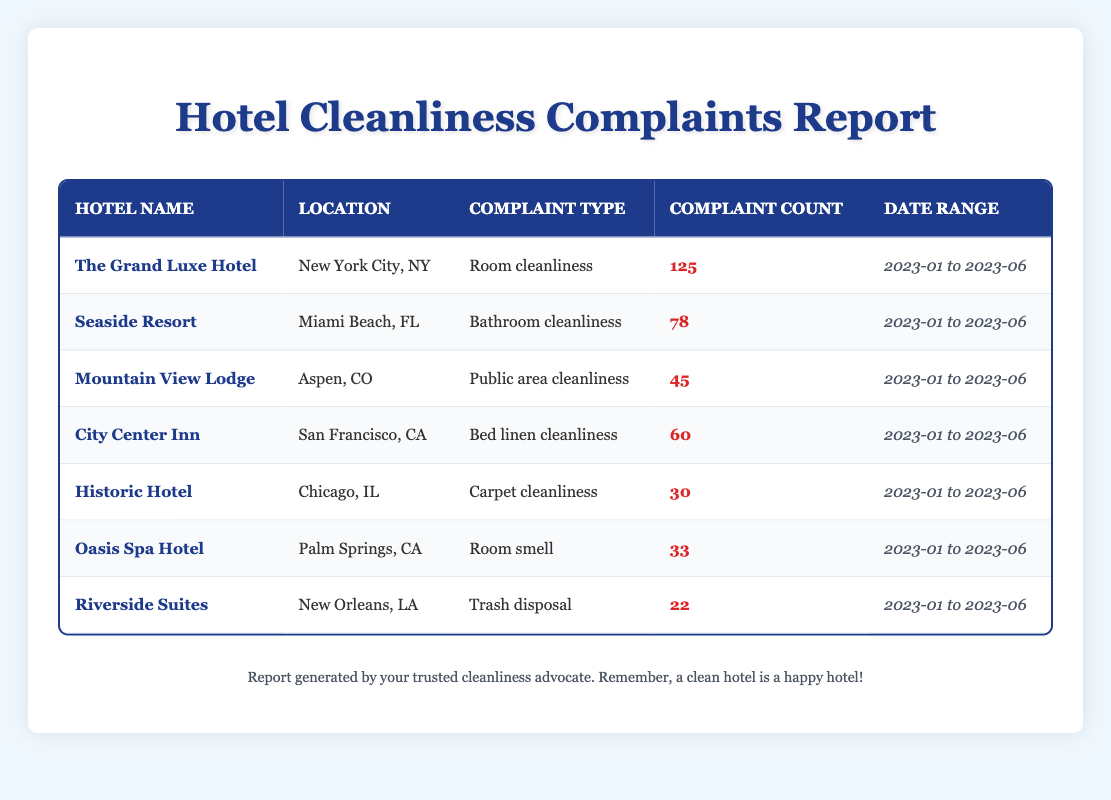What hotel had the highest number of cleanliness-related complaints? By reviewing the data in the table, we can see that "The Grand Luxe Hotel" has a complaint count of 125, which is the highest compared to other hotels listed.
Answer: The Grand Luxe Hotel Which hotel received complaints about bathroom cleanliness? Looking through the table, "Seaside Resort" is specifically noted for complaints related to bathroom cleanliness with a complaint count of 78.
Answer: Seaside Resort What is the total number of complaints related to cleanliness for the hotels listed? To find the total, we sum the complaint counts for all hotels: 125 + 78 + 45 + 60 + 30 + 33 + 22 = 393.
Answer: 393 Is there a hotel that received 22 complaints? Yes, "Riverside Suites" received exactly 22 complaints, as stated in the table.
Answer: Yes Which hotel has complaints related to public area cleanliness? According to the table, "Mountain View Lodge" is the hotel that received complaints about public area cleanliness, with a count of 45.
Answer: Mountain View Lodge What type of complaint did "Oasis Spa Hotel" receive and how many were there? "Oasis Spa Hotel" received complaints about room smell, and the complaint count is 33, as shown in the table.
Answer: Room smell, 33 Which hotel had more complaints about carpet cleanliness than trash disposal? Comparing the complaint counts, "Historic Hotel" had 30 complaints about carpet cleanliness, while "Riverside Suites" had only 22 complaints about trash disposal, indicating that "Historic Hotel" had more complaints in this category.
Answer: Historic Hotel What is the average number of cleanliness-related complaints among all hotels listed? To calculate the average, we first sum the complaints (393) and divide by the number of hotels (7): 393 / 7 = 56.14. Thus, the average number of complaints is approximately 56.14.
Answer: 56.14 Which hotel has the lowest number of cleanliness complaints and how many? From the table data, "Riverside Suites" has the lowest complaint count at 22, indicating it received the least number of cleanliness-related complaints among the listed hotels.
Answer: Riverside Suites, 22 